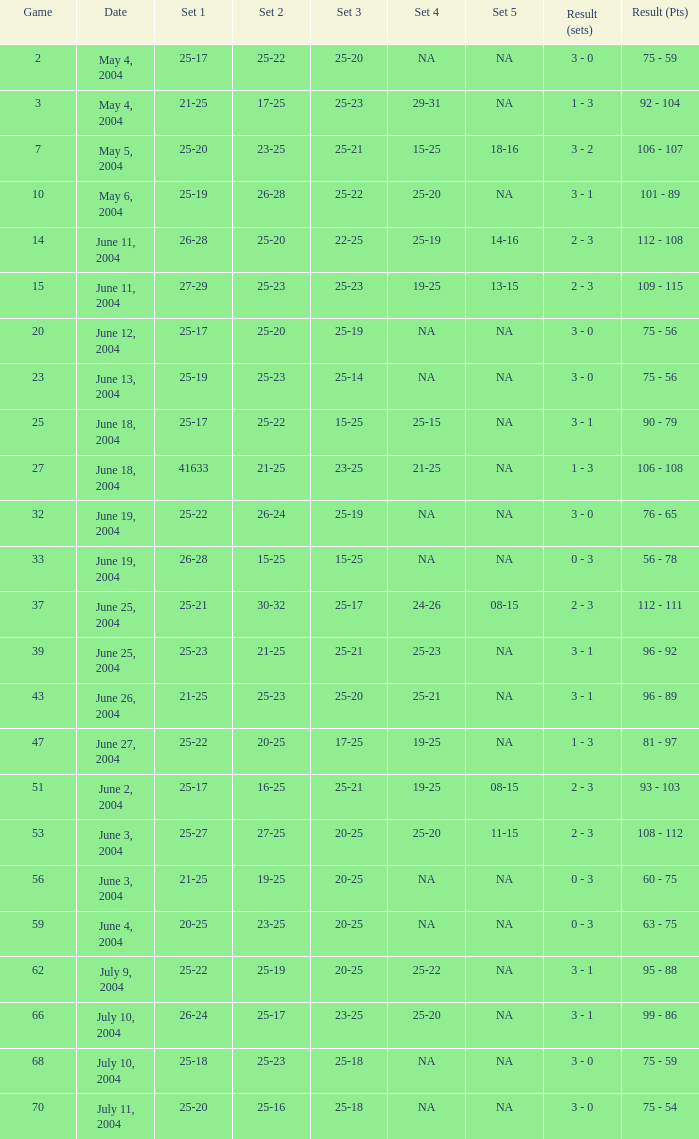What is the set 5 for the match with a set 2 of 21-25 and a set 1 of 41633? NA. 